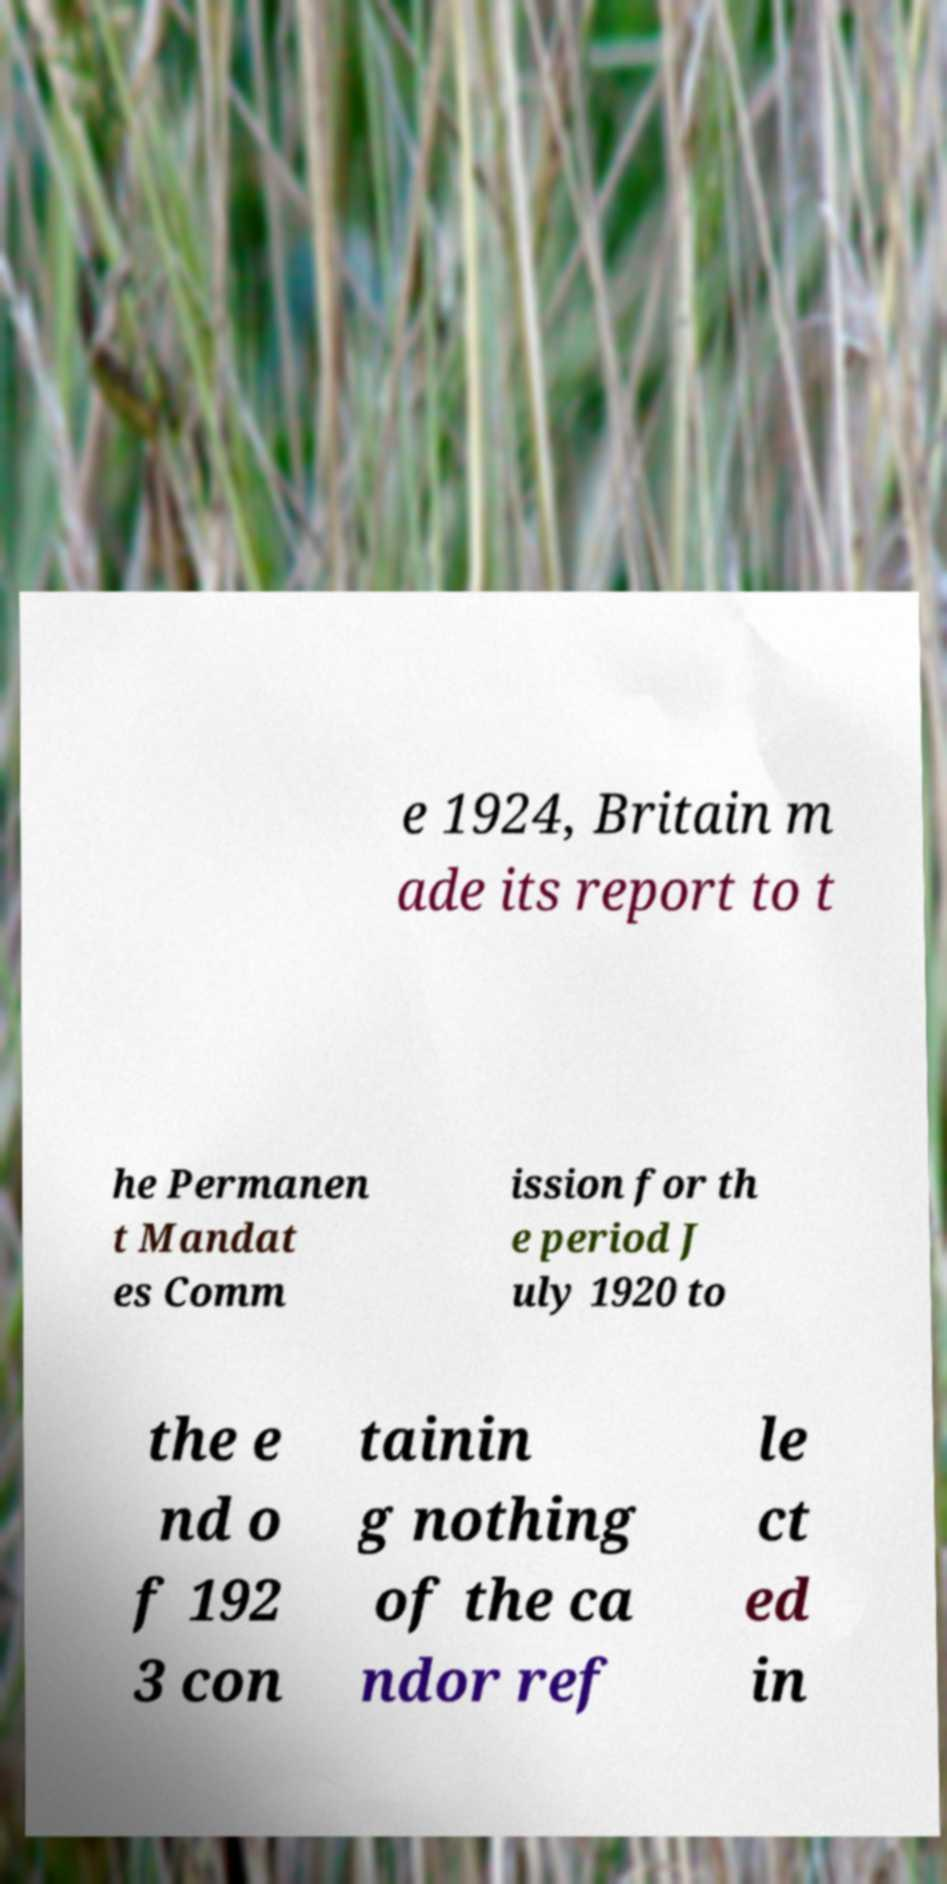There's text embedded in this image that I need extracted. Can you transcribe it verbatim? e 1924, Britain m ade its report to t he Permanen t Mandat es Comm ission for th e period J uly 1920 to the e nd o f 192 3 con tainin g nothing of the ca ndor ref le ct ed in 